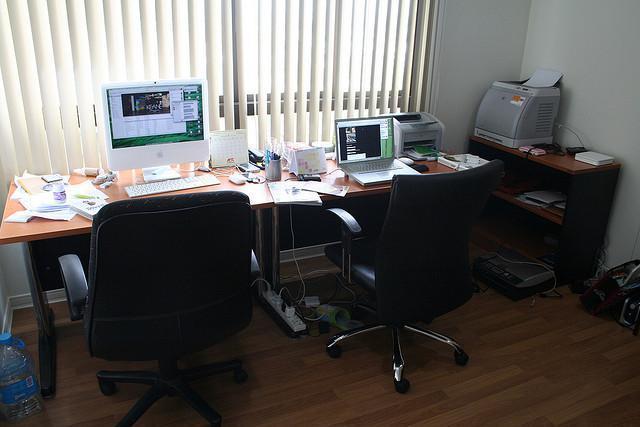How many printers are there?
Give a very brief answer. 2. How many chairs are there?
Give a very brief answer. 2. 